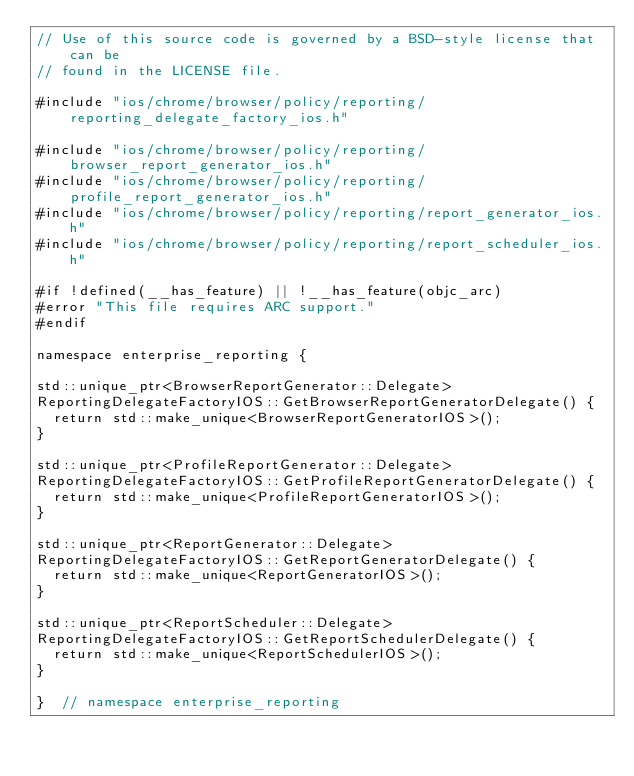<code> <loc_0><loc_0><loc_500><loc_500><_ObjectiveC_>// Use of this source code is governed by a BSD-style license that can be
// found in the LICENSE file.

#include "ios/chrome/browser/policy/reporting/reporting_delegate_factory_ios.h"

#include "ios/chrome/browser/policy/reporting/browser_report_generator_ios.h"
#include "ios/chrome/browser/policy/reporting/profile_report_generator_ios.h"
#include "ios/chrome/browser/policy/reporting/report_generator_ios.h"
#include "ios/chrome/browser/policy/reporting/report_scheduler_ios.h"

#if !defined(__has_feature) || !__has_feature(objc_arc)
#error "This file requires ARC support."
#endif

namespace enterprise_reporting {

std::unique_ptr<BrowserReportGenerator::Delegate>
ReportingDelegateFactoryIOS::GetBrowserReportGeneratorDelegate() {
  return std::make_unique<BrowserReportGeneratorIOS>();
}

std::unique_ptr<ProfileReportGenerator::Delegate>
ReportingDelegateFactoryIOS::GetProfileReportGeneratorDelegate() {
  return std::make_unique<ProfileReportGeneratorIOS>();
}

std::unique_ptr<ReportGenerator::Delegate>
ReportingDelegateFactoryIOS::GetReportGeneratorDelegate() {
  return std::make_unique<ReportGeneratorIOS>();
}

std::unique_ptr<ReportScheduler::Delegate>
ReportingDelegateFactoryIOS::GetReportSchedulerDelegate() {
  return std::make_unique<ReportSchedulerIOS>();
}

}  // namespace enterprise_reporting
</code> 